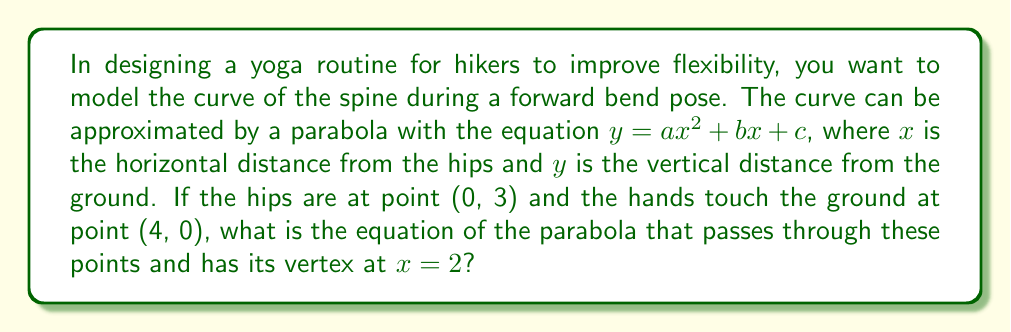Solve this math problem. Let's approach this step-by-step:

1) We know the parabola passes through two points:
   (0, 3) and (4, 0)

2) We also know the vertex is at $x = 2$. For a parabola $y = a(x-h)^2 + k$, where (h,k) is the vertex, we can write:
   $y = a(x-2)^2 + k$

3) Expanding this:
   $y = ax^2 - 4ax + 4a + k$

4) Comparing with the standard form $y = ax^2 + bx + c$, we see that:
   $b = -4a$
   $c = 4a + k$

5) Now, let's use the two points we know:
   For (0, 3): $3 = 4a + k$
   For (4, 0): $0 = 16a - 16a + 4a + k = 4a + k$

6) From step 5, we can see that $3 = 4a + k$ and $0 = 4a + k$
   Subtracting these equations:
   $3 = 4a + k - (4a + k) = 0$
   $3 = 0$

7) This is impossible unless $a = -\frac{3}{4}$ (because the difference between y-values is 3 over a span of 4 in x)

8) Substituting back:
   $k = 0 - 4a = 0 - 4(-\frac{3}{4}) = 3$

9) Therefore, the equation is:
   $y = -\frac{3}{4}(x-2)^2 + 3$

10) Expanding this:
    $y = -\frac{3}{4}x^2 + 3x + 0$

This is our final equation in the form $y = ax^2 + bx + c$.
Answer: $y = -\frac{3}{4}x^2 + 3x$ 